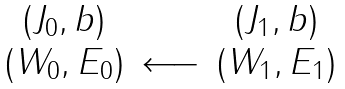Convert formula to latex. <formula><loc_0><loc_0><loc_500><loc_500>\begin{array} { c c c } ( J _ { 0 } , b ) & & ( J _ { 1 } , b ) \\ ( { W } _ { 0 } , { E } _ { 0 } ) & \longleftarrow & ( { W } _ { 1 } , { E } _ { 1 } ) \end{array}</formula> 